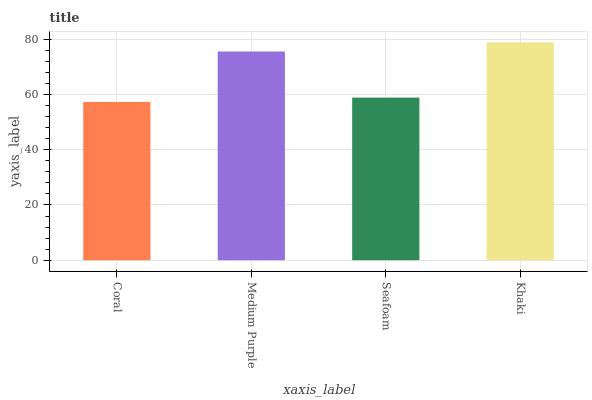Is Coral the minimum?
Answer yes or no. Yes. Is Khaki the maximum?
Answer yes or no. Yes. Is Medium Purple the minimum?
Answer yes or no. No. Is Medium Purple the maximum?
Answer yes or no. No. Is Medium Purple greater than Coral?
Answer yes or no. Yes. Is Coral less than Medium Purple?
Answer yes or no. Yes. Is Coral greater than Medium Purple?
Answer yes or no. No. Is Medium Purple less than Coral?
Answer yes or no. No. Is Medium Purple the high median?
Answer yes or no. Yes. Is Seafoam the low median?
Answer yes or no. Yes. Is Seafoam the high median?
Answer yes or no. No. Is Medium Purple the low median?
Answer yes or no. No. 